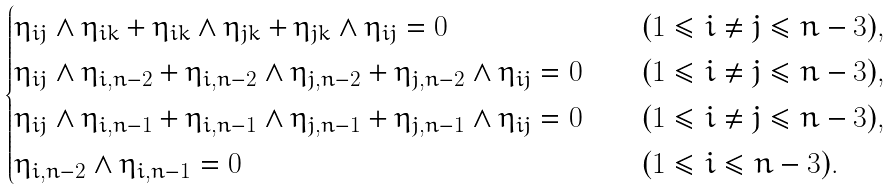Convert formula to latex. <formula><loc_0><loc_0><loc_500><loc_500>\begin{cases} \eta _ { i j } \wedge \eta _ { i k } + \eta _ { i k } \wedge \eta _ { j k } + \eta _ { j k } \wedge \eta _ { i j } = 0 & ( 1 \leq i \neq j \leq n - 3 ) , \\ \eta _ { i j } \wedge \eta _ { i , n - 2 } + \eta _ { i , n - 2 } \wedge \eta _ { j , n - 2 } + \eta _ { j , n - 2 } \wedge \eta _ { i j } = 0 \quad & ( 1 \leq i \neq j \leq n - 3 ) , \\ \eta _ { i j } \wedge \eta _ { i , n - 1 } + \eta _ { i , n - 1 } \wedge \eta _ { j , n - 1 } + \eta _ { j , n - 1 } \wedge \eta _ { i j } = 0 & ( 1 \leq i \neq j \leq n - 3 ) , \\ \eta _ { i , n - 2 } \wedge \eta _ { i , n - 1 } = 0 & ( 1 \leq i \leq n - 3 ) . \end{cases}</formula> 